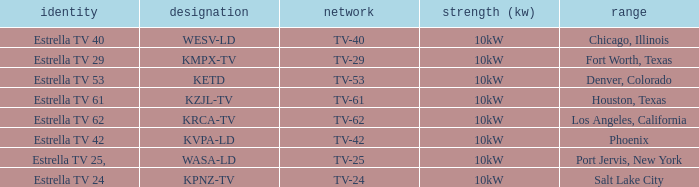List the branding for krca-tv. Estrella TV 62. 